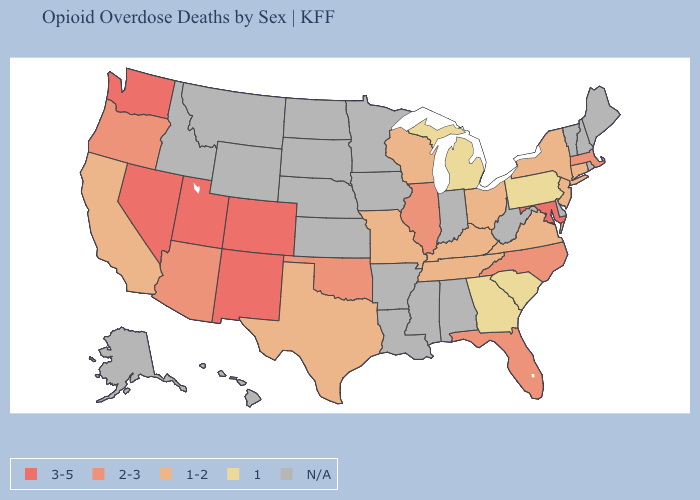What is the highest value in states that border Wyoming?
Quick response, please. 3-5. Does the map have missing data?
Answer briefly. Yes. What is the value of Rhode Island?
Concise answer only. N/A. Does the first symbol in the legend represent the smallest category?
Answer briefly. No. Does New Mexico have the highest value in the West?
Be succinct. Yes. Name the states that have a value in the range 3-5?
Concise answer only. Colorado, Maryland, Nevada, New Mexico, Utah, Washington. What is the lowest value in the South?
Keep it brief. 1. What is the value of Missouri?
Concise answer only. 1-2. Name the states that have a value in the range 3-5?
Short answer required. Colorado, Maryland, Nevada, New Mexico, Utah, Washington. Among the states that border North Carolina , which have the lowest value?
Give a very brief answer. Georgia, South Carolina. What is the value of Wyoming?
Answer briefly. N/A. Does the first symbol in the legend represent the smallest category?
Be succinct. No. Which states hav the highest value in the South?
Short answer required. Maryland. Which states hav the highest value in the West?
Write a very short answer. Colorado, Nevada, New Mexico, Utah, Washington. 